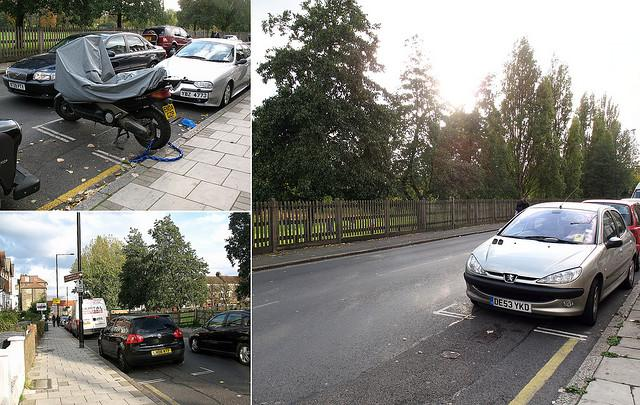What does the grey cloth do?

Choices:
A) hide motorcycle
B) prevent scratches
C) prevent bugs
D) keep dry keep dry 